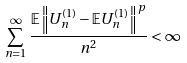<formula> <loc_0><loc_0><loc_500><loc_500>\sum _ { n = 1 } ^ { \infty } \frac { \mathbb { E } \left \| U _ { n } ^ { ( 1 ) } - \mathbb { E } U _ { n } ^ { ( 1 ) } \right \| ^ { p } } { n ^ { 2 } } < \infty</formula> 